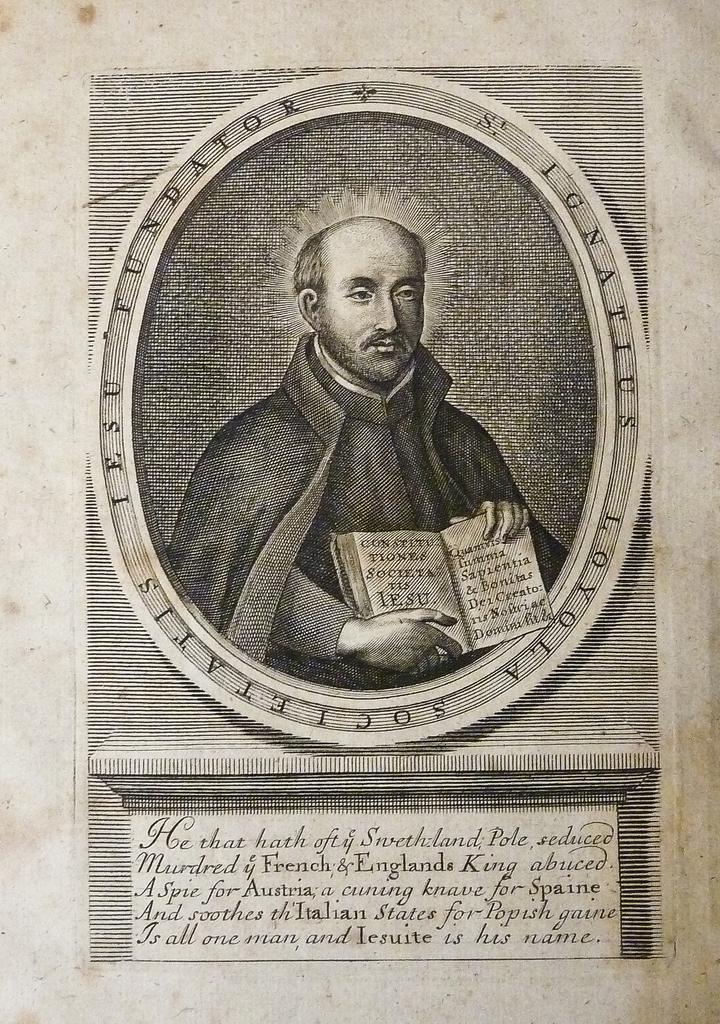What is on the wall in the image? There is a poster on the wall in the image. What is depicted on the poster? The poster features a person holding a book. Is there any text on the poster? Yes, there is text at the bottom of the poster. Can you tell me how many cherries are on the chessboard in the image? There is no chessboard or cherries present in the image; it only features a poster with a person holding a book. 